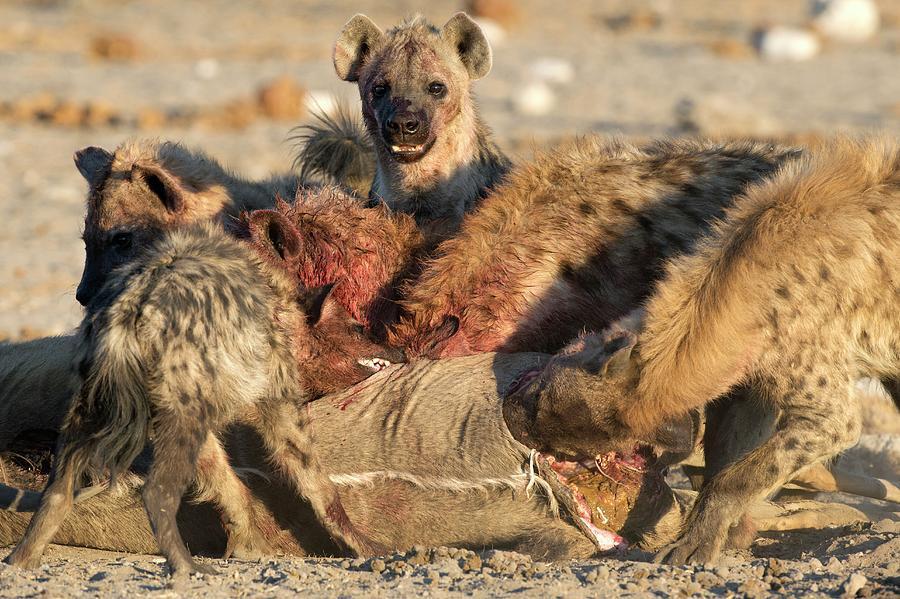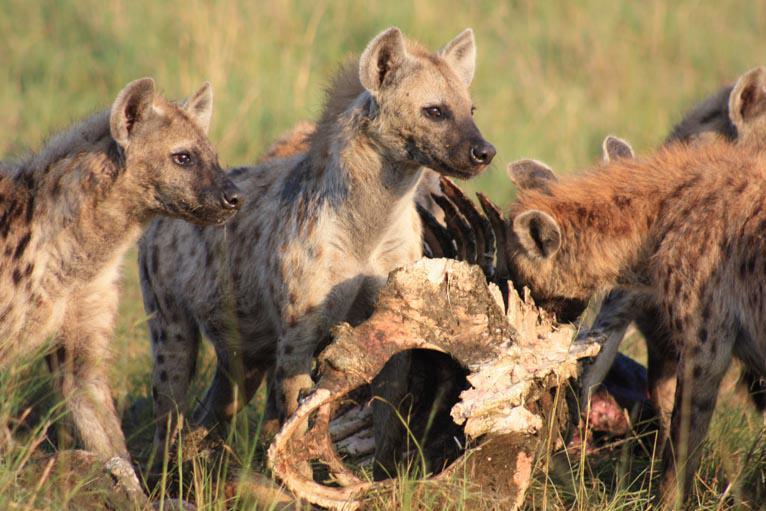The first image is the image on the left, the second image is the image on the right. For the images shown, is this caption "Multiple hyena are standing behind a carcass with the horn of a hooved animal in front of them, including a leftward-turned hyena with its mouth lowered to the carcass." true? Answer yes or no. No. 